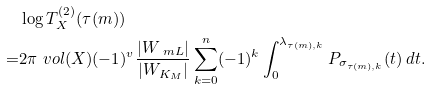<formula> <loc_0><loc_0><loc_500><loc_500>& \log T _ { X } ^ { ( 2 ) } ( \tau ( m ) ) \\ = & 2 \pi \ v o l ( X ) ( - 1 ) ^ { v } \frac { | W _ { \ m L } | } { | W _ { K _ { M } } | } \sum _ { k = 0 } ^ { n } ( - 1 ) ^ { k } \int _ { 0 } ^ { \lambda _ { \tau ( m ) , k } } P _ { \sigma _ { \tau ( m ) , k } } ( t ) \, d t .</formula> 